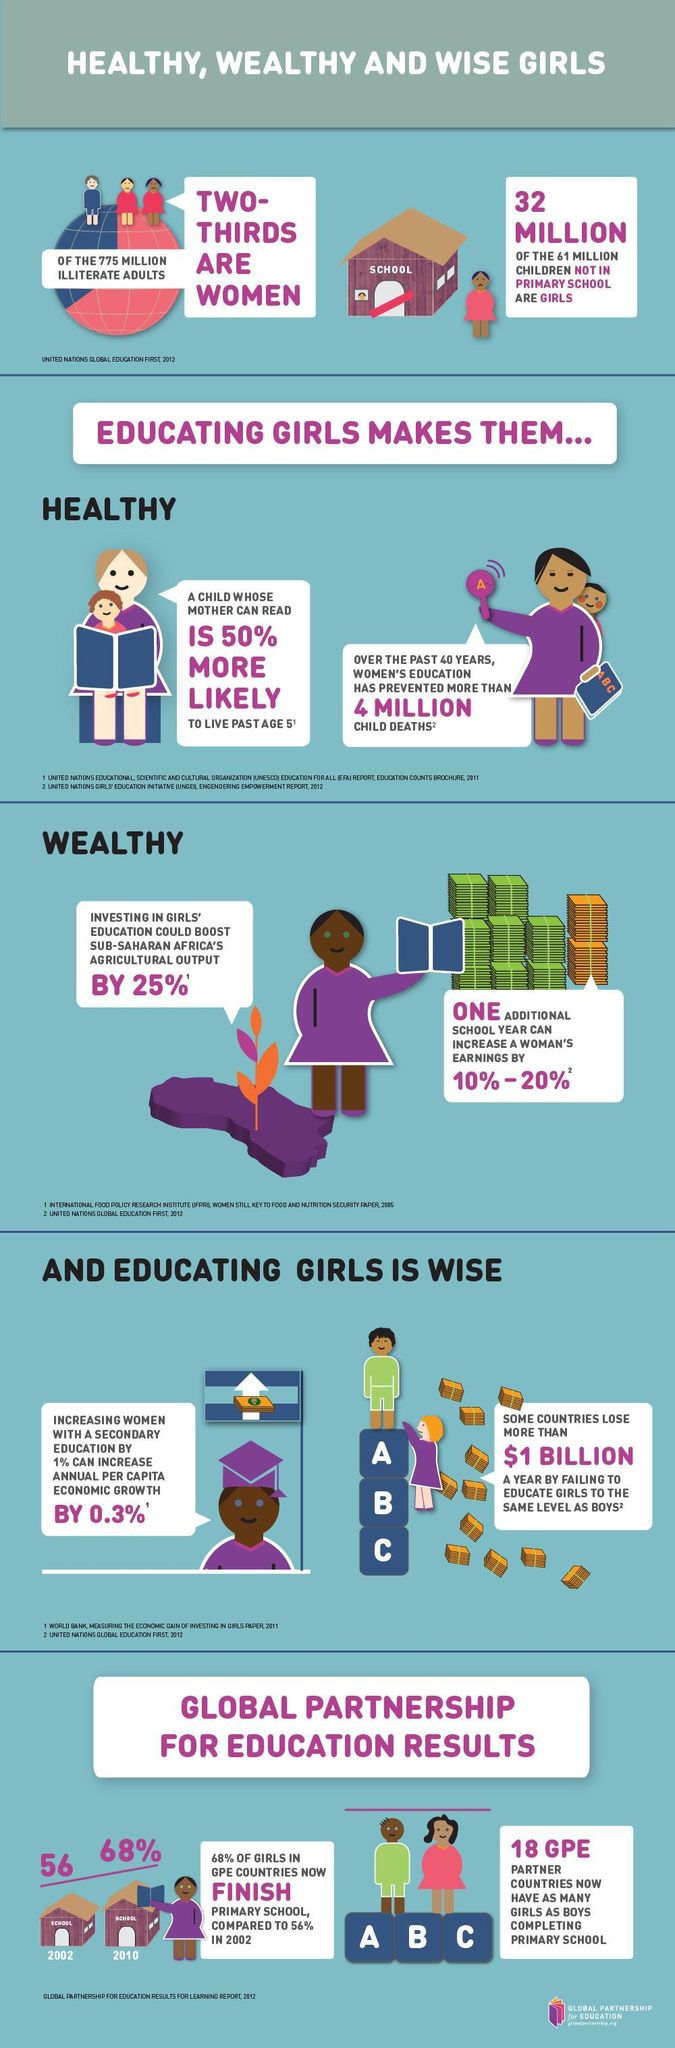What has been the percentage growth in girls finishing primary school in 2010 versus 2002?
Answer the question with a short phrase. 12% What does educating girls make them? Healthy, Wealthy, Wise How many boys do not attend primary school ? 29 Million 